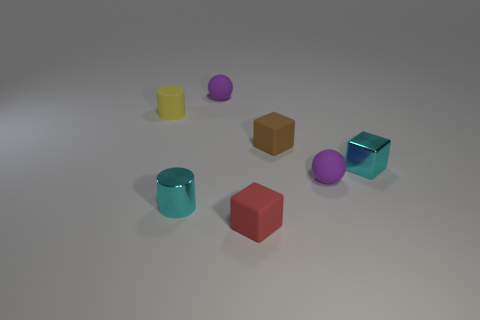Add 3 matte things. How many objects exist? 10 Subtract all small green shiny objects. Subtract all tiny cyan metal cylinders. How many objects are left? 6 Add 4 small shiny blocks. How many small shiny blocks are left? 5 Add 4 yellow cylinders. How many yellow cylinders exist? 5 Subtract 0 red cylinders. How many objects are left? 7 Subtract all balls. How many objects are left? 5 